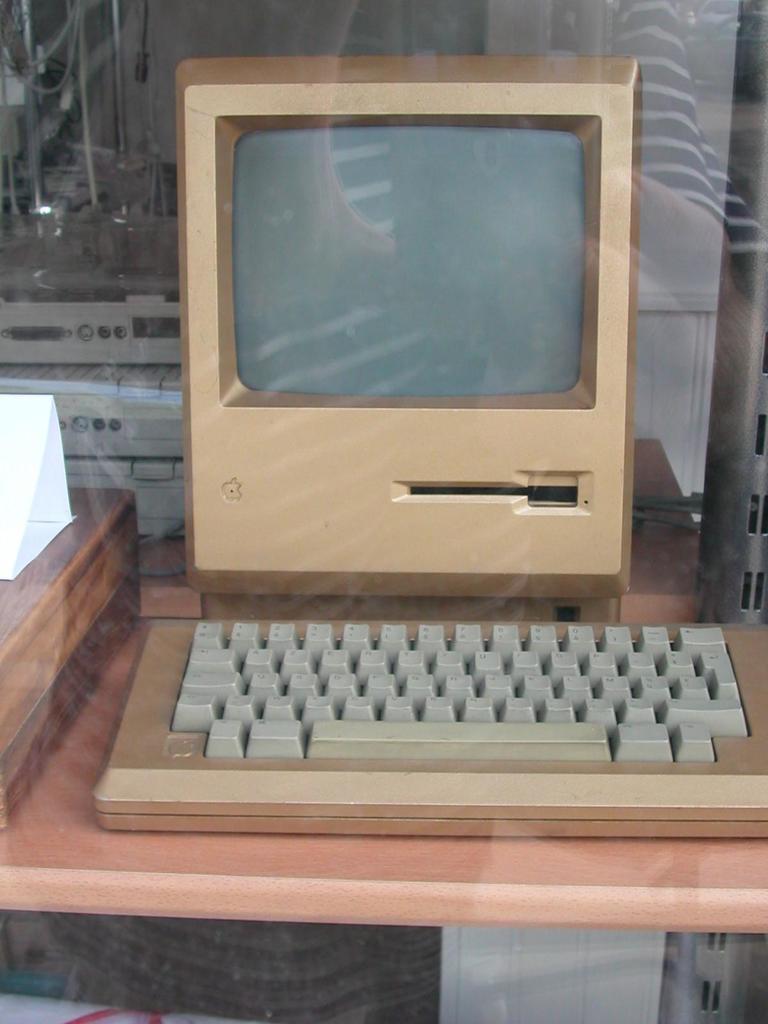Can you describe this image briefly? In this image, we can see a monitor, keyboard and wooden object are placed on the wooden surface. Here we can see a glass. On the glass we can see person reflection. Background we can see few things and rods. 